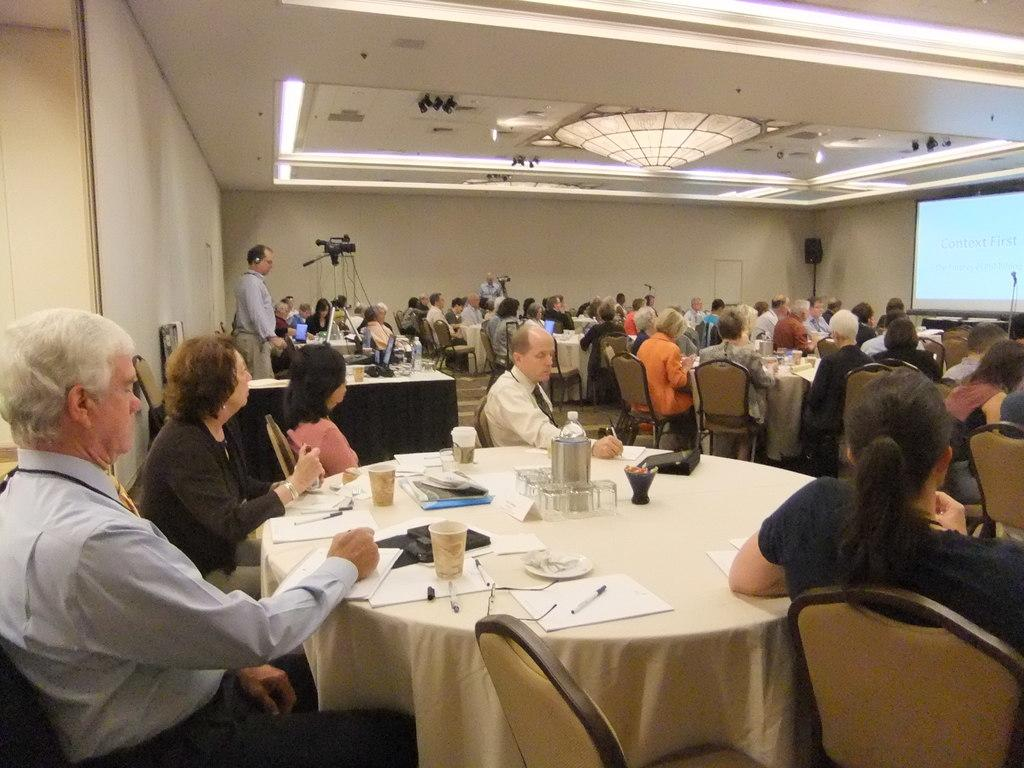How many people are in the image? There is a group of people in the image. What are the people doing in the image? The people are sitting in front of a table. What are the people sitting on? The people are sitting on chairs. What is the large screen in the image used for? There is a projector screen in the image. What type of authority figure is present in the image? There is no authority figure present in the image. How many friends are visible in the image? The term "friends" is not mentioned in the provided facts, so it cannot be determined from the image. 